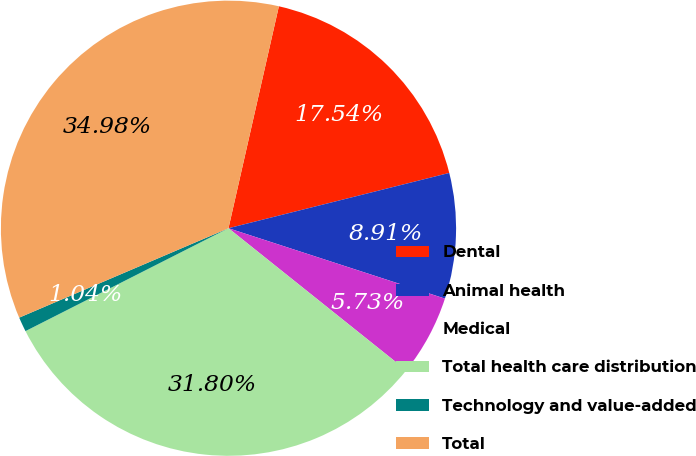Convert chart. <chart><loc_0><loc_0><loc_500><loc_500><pie_chart><fcel>Dental<fcel>Animal health<fcel>Medical<fcel>Total health care distribution<fcel>Technology and value-added<fcel>Total<nl><fcel>17.54%<fcel>8.91%<fcel>5.73%<fcel>31.8%<fcel>1.04%<fcel>34.98%<nl></chart> 